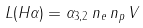<formula> <loc_0><loc_0><loc_500><loc_500>L ( H \alpha ) = \alpha _ { 3 , 2 } \, n _ { e } \, n _ { p } \, V</formula> 